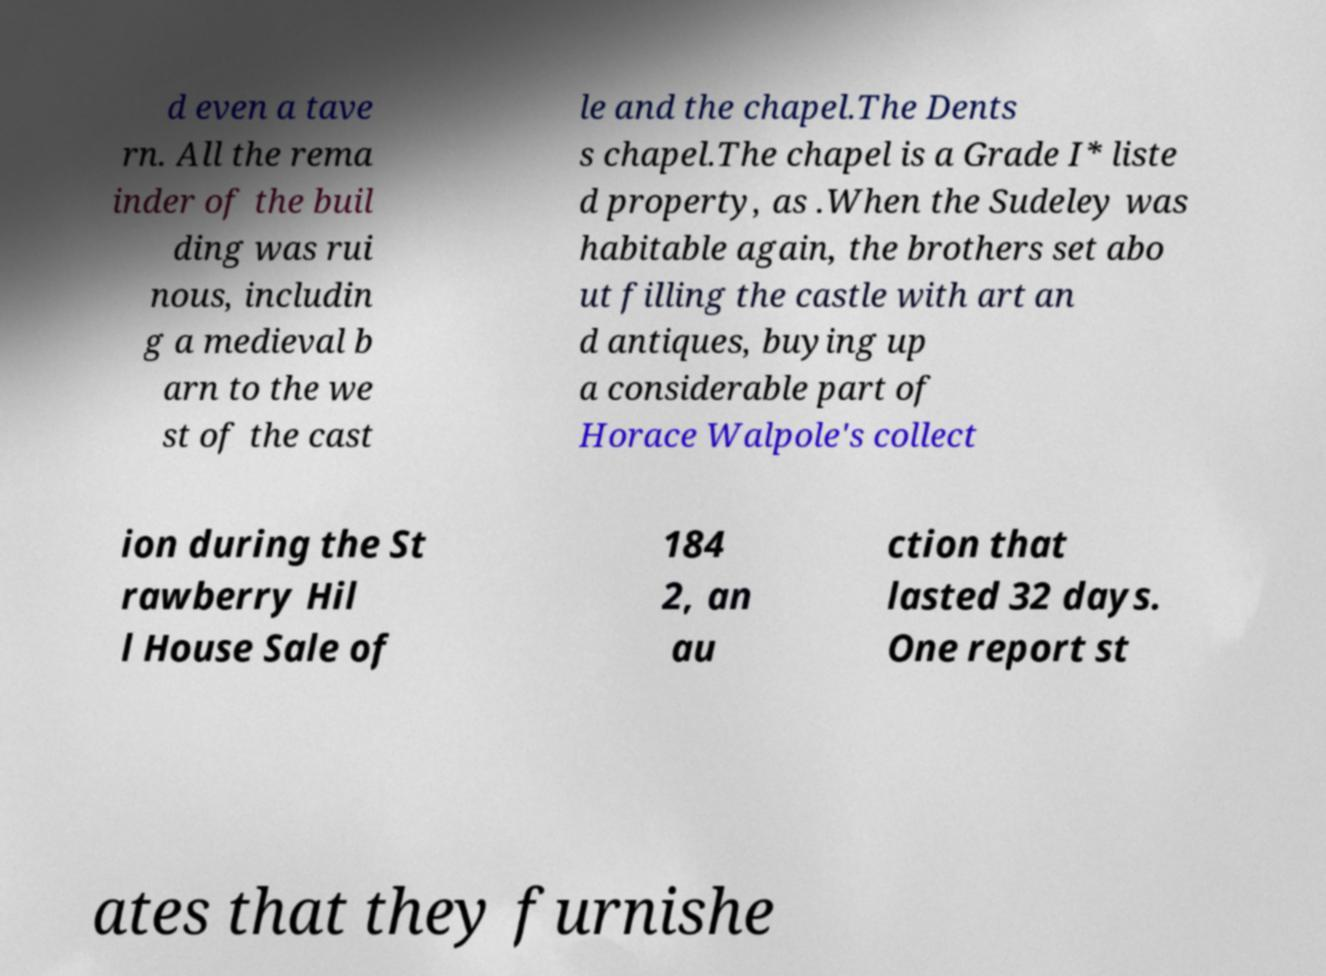Please identify and transcribe the text found in this image. d even a tave rn. All the rema inder of the buil ding was rui nous, includin g a medieval b arn to the we st of the cast le and the chapel.The Dents s chapel.The chapel is a Grade I* liste d property, as .When the Sudeley was habitable again, the brothers set abo ut filling the castle with art an d antiques, buying up a considerable part of Horace Walpole's collect ion during the St rawberry Hil l House Sale of 184 2, an au ction that lasted 32 days. One report st ates that they furnishe 